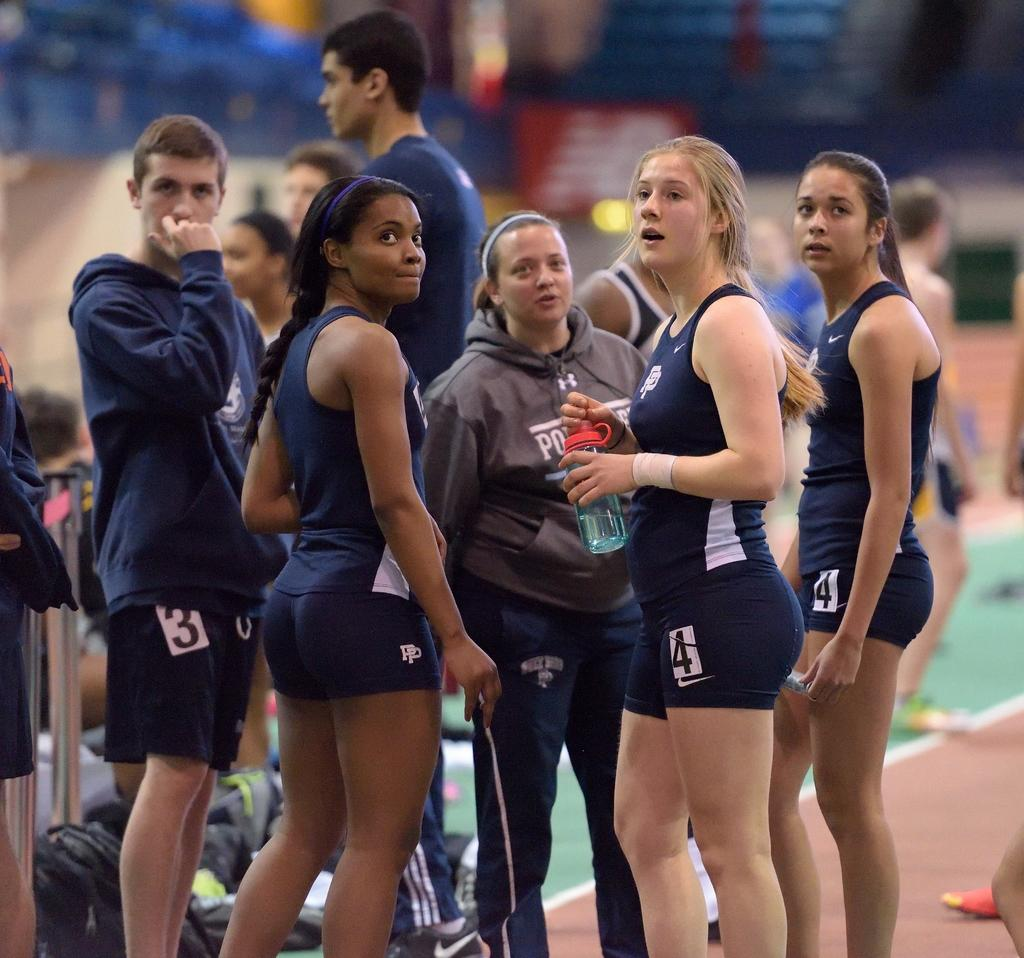Who can be seen in the image? There are people in the image. What is the woman holding in the image? The woman is holding a bottle in the image. What else can be seen in the image besides people? There are bags visible in the image. Can you describe the background of the image? The background of the image is blurry. What type of polish is being applied to the stage in the image? There is no stage or polish present in the image. What word is being emphasized by the people in the image? There is no specific word being emphasized by the people in the image. 